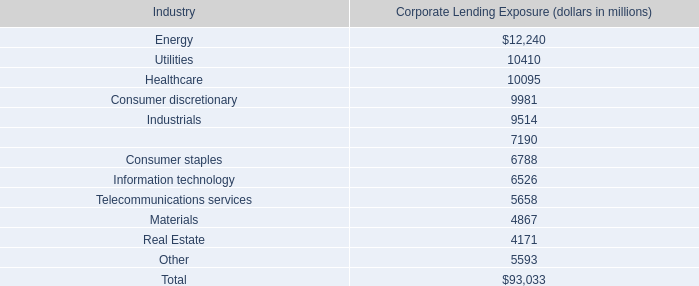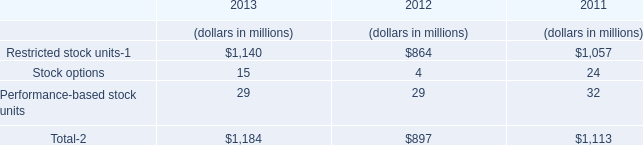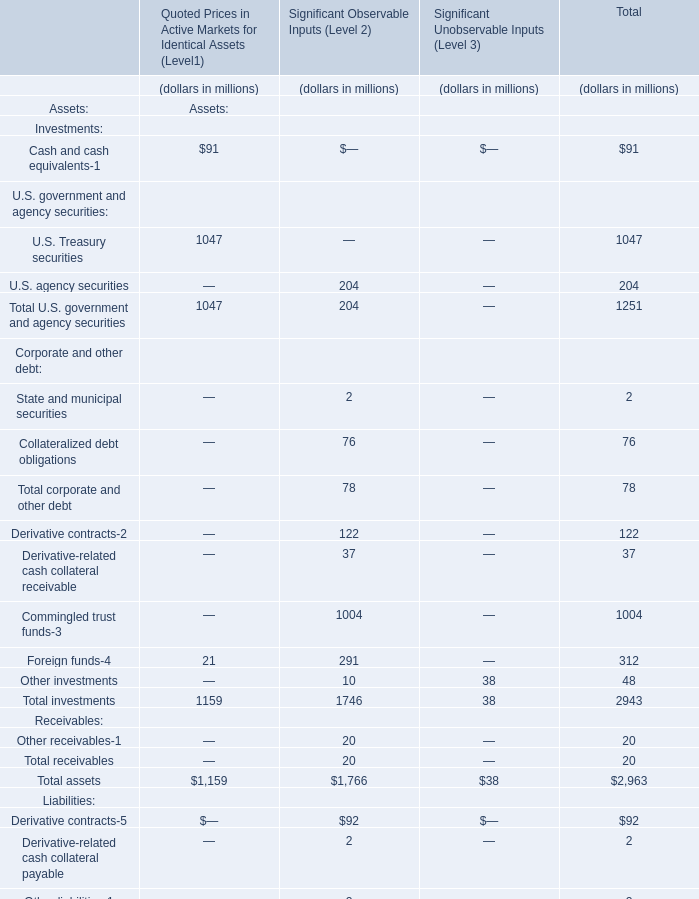What is the sum of U.S. Treasury securities for Quoted Prices in Active Markets for Identical Assets (Level1) and Restricted stock units-1 in 2013? (in million) 
Computations: (1047 + 1140)
Answer: 2187.0. 